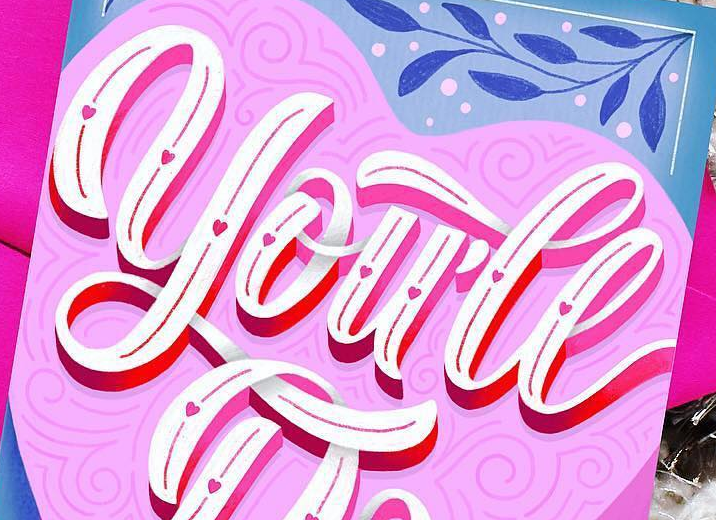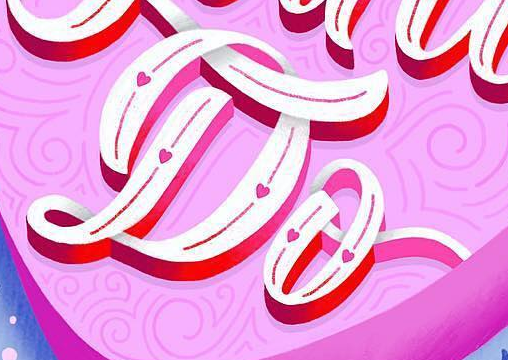What words are shown in these images in order, separated by a semicolon? you'll; Do 